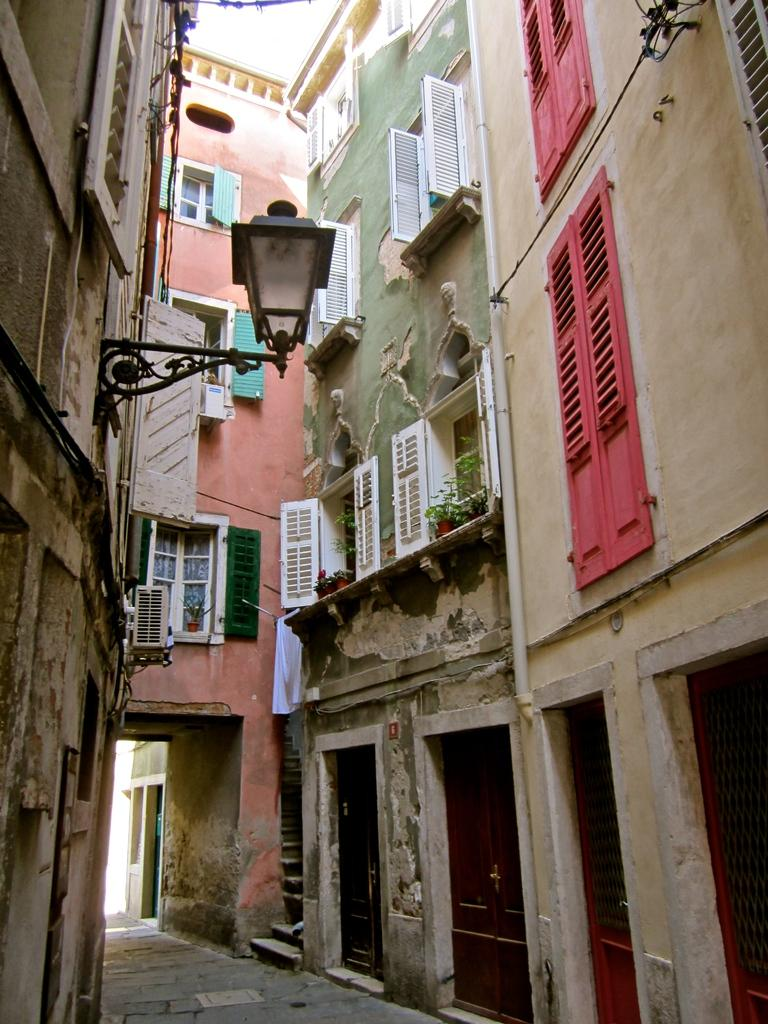What is the main subject of the image? The main subject of the image is a street. What can be seen on the left side of the image? There are buildings on the left side of the image. What can be seen on the right side of the image? There are buildings on the right side of the image. Can you describe any specific features of the buildings in the image? Yes, there is a lamp attached to a building stock in the image. What type of creature is walking down the street in the image? There is no creature present in the image; it only features a street and buildings. How many accounts are visible in the image? There are no accounts visible in the image, as it does not contain any financial or personal information. 